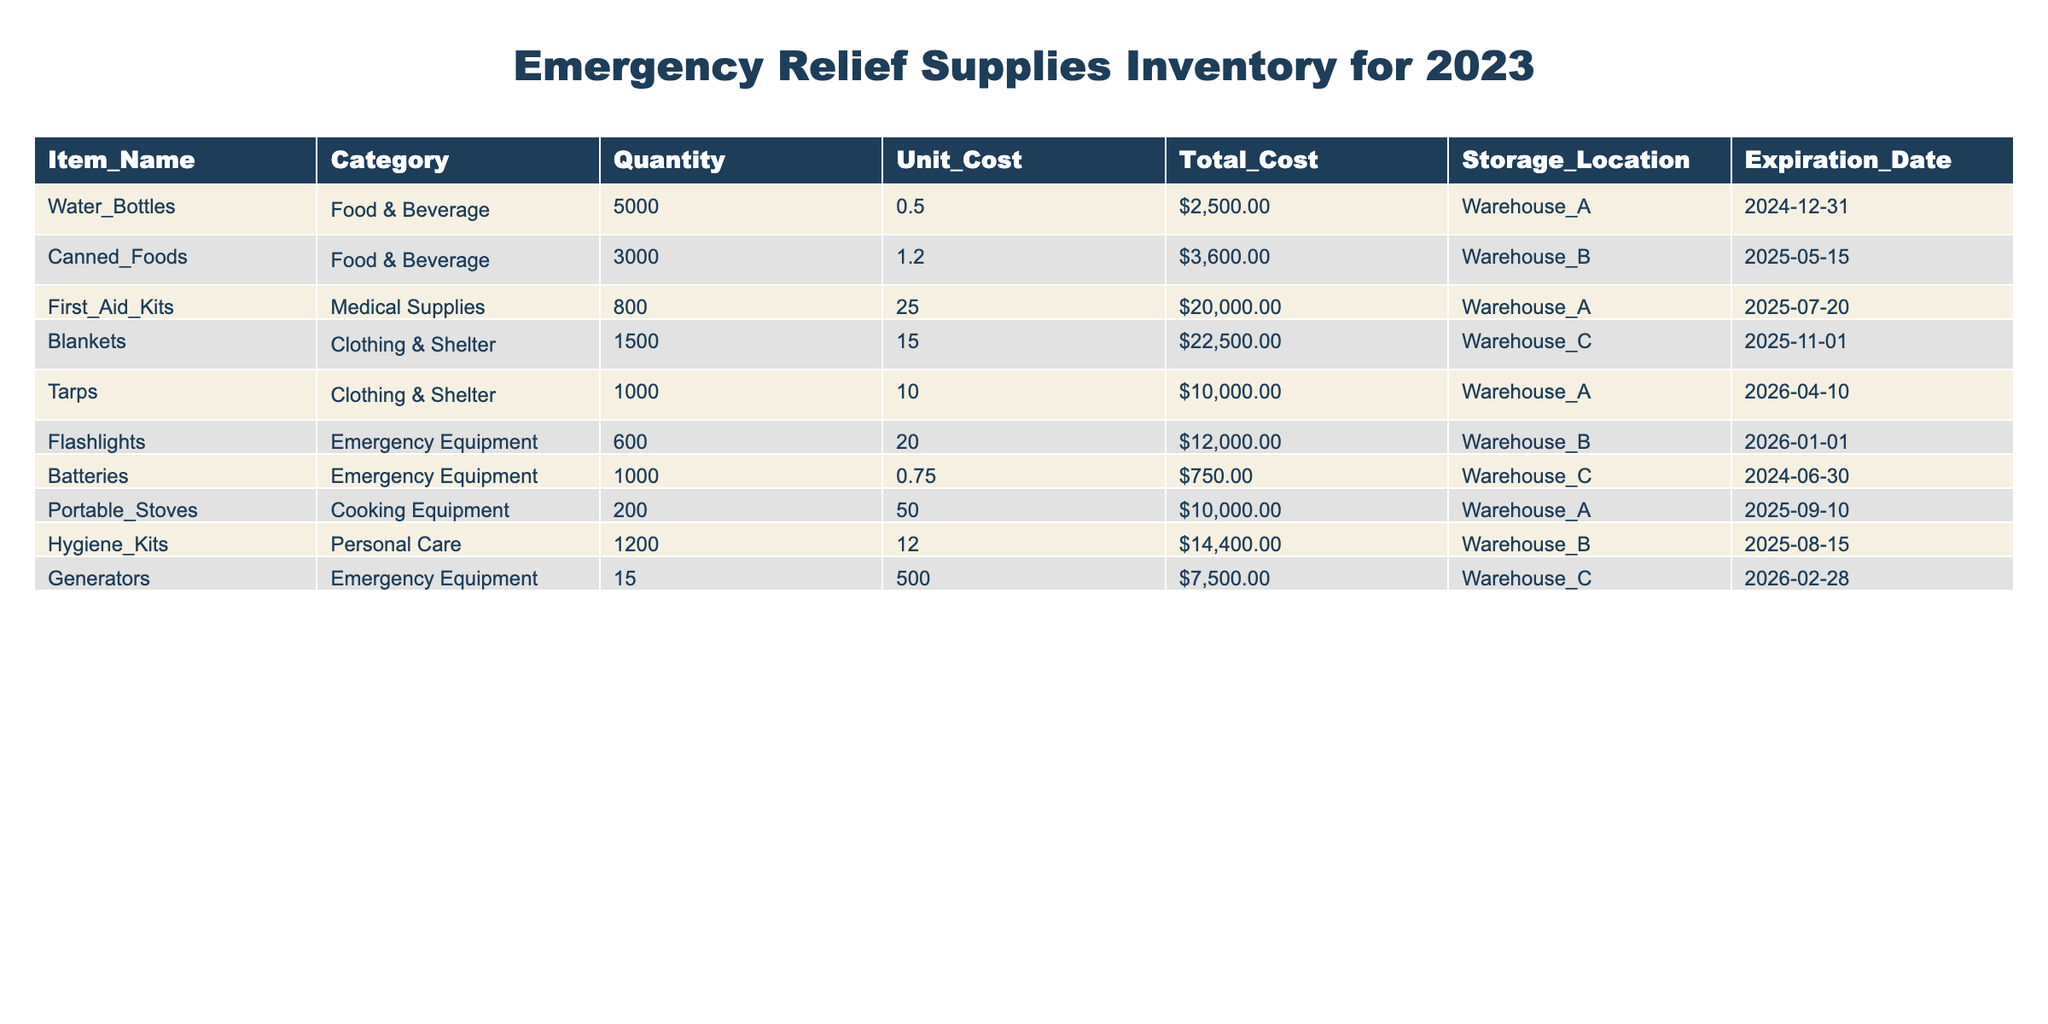What is the total quantity of food and beverage items in the inventory? To find the total quantity, we can add the quantities of Water Bottles and Canned Foods, which are the only food and beverage items listed. Water Bottles have a quantity of 5000 and Canned Foods have a quantity of 3000. So, the total quantity is 5000 + 3000 = 8000.
Answer: 8000 How many First Aid Kits are available in total? The total quantity of First Aid Kits is directly provided in the table. We find that there are 800 First Aid Kits available.
Answer: 800 Are there any items in the inventory with an expiration date later than January 1, 2026? Looking at the expiration dates, we see that Tarps expire on April 10, 2026, and Flashlights expire on January 1, 2026. Therefore, Tarps is the only item that has an expiration date later than January 1, 2026.
Answer: Yes What is the total cost of all emergency equipment items? We need to calculate the total cost of emergency equipment, which includes Flashlights, Batteries, and Generators. Their total costs are: Flashlights ($12000) + Batteries ($750.00) + Generators ($7500.00). Adding these together gives us $12000 + $750 + $7500 = $20250.
Answer: 20250 What is the average unit cost of clothing and shelter items? The clothing and shelter items in the inventory are Blankets and Tarps. Their unit costs are $15.00 for Blankets and $10.00 for Tarps. To find the average, we sum these costs: $15.00 + $10.00 = $25.00. Then divide by the number of items (2): $25.00 / 2 = $12.50.
Answer: 12.50 Is the quantity of Batteries greater than that of Portable Stoves? Looking at the quantities, Batteries have a quantity of 1000, while Portable Stoves have a quantity of 200. Since 1000 is greater than 200, we can conclude that there are more Batteries than Portable Stoves.
Answer: Yes What is the total cost of all supplies categorized as Personal Care? The only item in the Personal Care category is Hygiene Kits, with a total cost of $14400. Thus, the total cost of Personal Care supplies is simply the cost of Hygiene Kits.
Answer: 14400 Which item has the highest total cost in the inventory? To identify which item has the highest total cost, we compare the total costs of each item. The highest total cost is for Blankets, which is $22500.
Answer: Blankets What is the difference in total cost between Food & Beverage items and Emergency Equipment items? First, we sum the total costs of Food & Beverage items. Water Bottles total $2500 and Canned Foods total $3600, which gives $2500 + $3600 = $6100. Next, we sum the total costs of Emergency Equipment items: Flashlights ($12000) + Batteries ($750) + Generators ($7500) = $20250. Finally, we find the difference: $20250 - $6100 = $14150.
Answer: 14150 